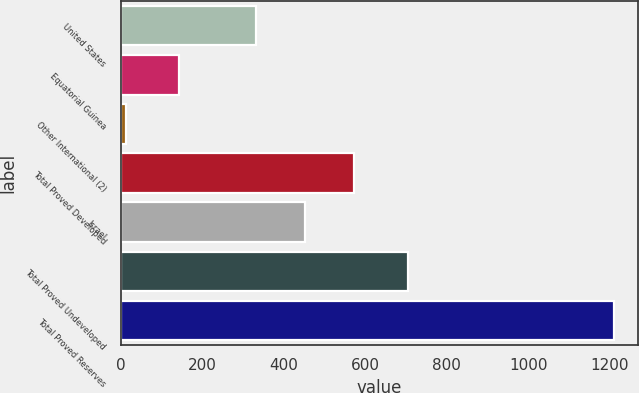Convert chart to OTSL. <chart><loc_0><loc_0><loc_500><loc_500><bar_chart><fcel>United States<fcel>Equatorial Guinea<fcel>Other International (2)<fcel>Total Proved Developed<fcel>Israel<fcel>Total Proved Undeveloped<fcel>Total Proved Reserves<nl><fcel>333<fcel>143<fcel>14<fcel>572<fcel>452.5<fcel>705<fcel>1209<nl></chart> 